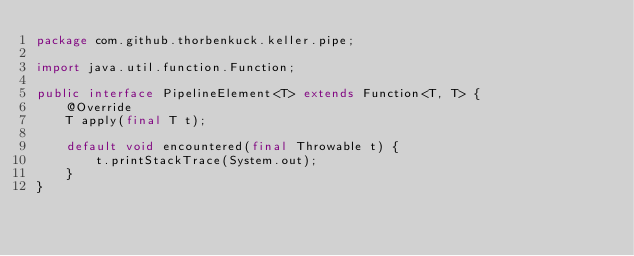Convert code to text. <code><loc_0><loc_0><loc_500><loc_500><_Java_>package com.github.thorbenkuck.keller.pipe;

import java.util.function.Function;

public interface PipelineElement<T> extends Function<T, T> {
	@Override
	T apply(final T t);

	default void encountered(final Throwable t) {
		t.printStackTrace(System.out);
	}
}
</code> 